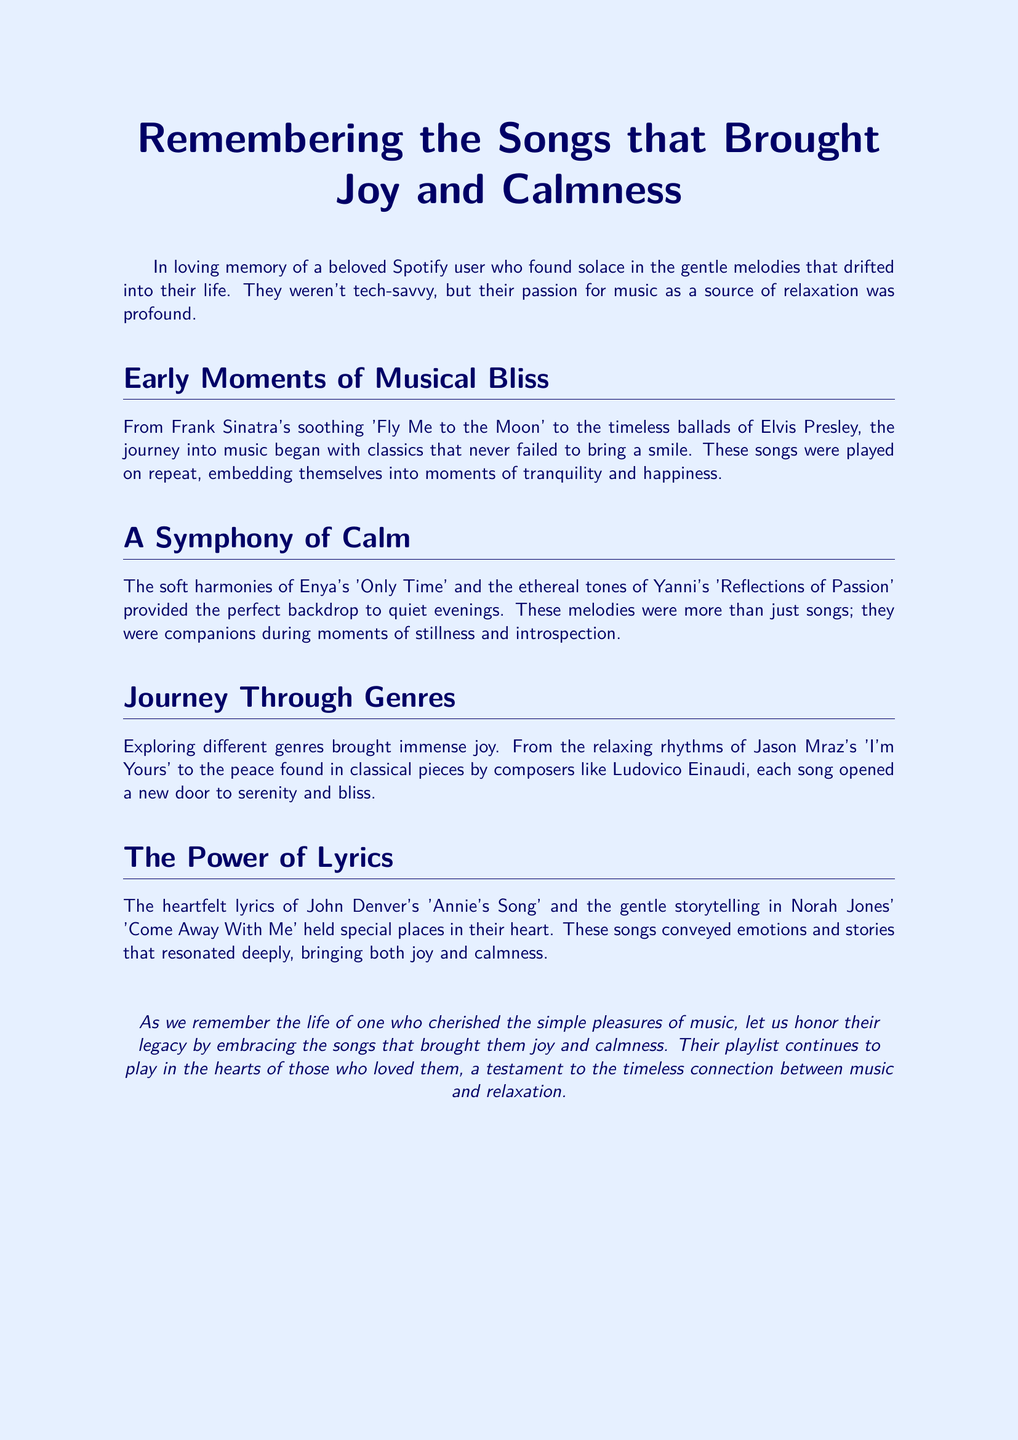What song is mentioned as a soothing classic? The document lists 'Fly Me to the Moon' by Frank Sinatra as a soothing classic.
Answer: 'Fly Me to the Moon' Which artist's songs are described as companions during stillness? Enya's music, particularly 'Only Time,' is referred to as a companion during moments of stillness and introspection.
Answer: Enya What genre did Jason Mraz belong to? The document describes Jason Mraz's 'I'm Yours' as part of relaxing rhythms, indicating he is in the pop genre.
Answer: Pop What was the heartfelt song by John Denver mentioned? The document specifically highlights 'Annie's Song' by John Denver as a song with heartfelt lyrics.
Answer: 'Annie's Song' What kind of songs does the obituary emphasize? The obituary emphasizes songs that brought joy and calmness to the individual being remembered.
Answer: Joy and calmness Who provided a perfect backdrop for quiet evenings? The document mentions that the soft harmonies of Enya provided a perfect backdrop for quiet evenings.
Answer: Enya What season of the individual's life does the document reflect? The document reflects on moments of tranquility and happiness in the individual's life through music.
Answer: Tranquility and happiness What does the obituary suggest about the connection between music and relaxation? It suggests that there is a timeless connection between music and relaxation, as evidenced by the person's cherished songs.
Answer: Timeless connection 